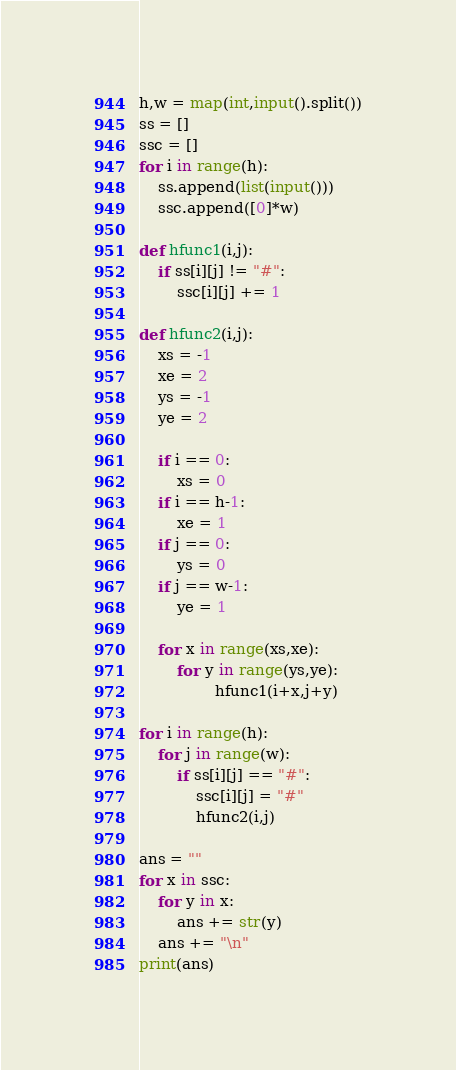Convert code to text. <code><loc_0><loc_0><loc_500><loc_500><_Python_>h,w = map(int,input().split())
ss = []
ssc = []
for i in range(h):
    ss.append(list(input()))
    ssc.append([0]*w)

def hfunc1(i,j):
    if ss[i][j] != "#":
        ssc[i][j] += 1

def hfunc2(i,j):
    xs = -1
    xe = 2
    ys = -1
    ye = 2

    if i == 0:
        xs = 0
    if i == h-1:
        xe = 1
    if j == 0:
        ys = 0
    if j == w-1:
        ye = 1 

    for x in range(xs,xe):
        for y in range(ys,ye):
                hfunc1(i+x,j+y)
    
for i in range(h):
    for j in range(w):
        if ss[i][j] == "#":
            ssc[i][j] = "#"
            hfunc2(i,j)

ans = ""
for x in ssc:
    for y in x:
        ans += str(y)
    ans += "\n"
print(ans)</code> 